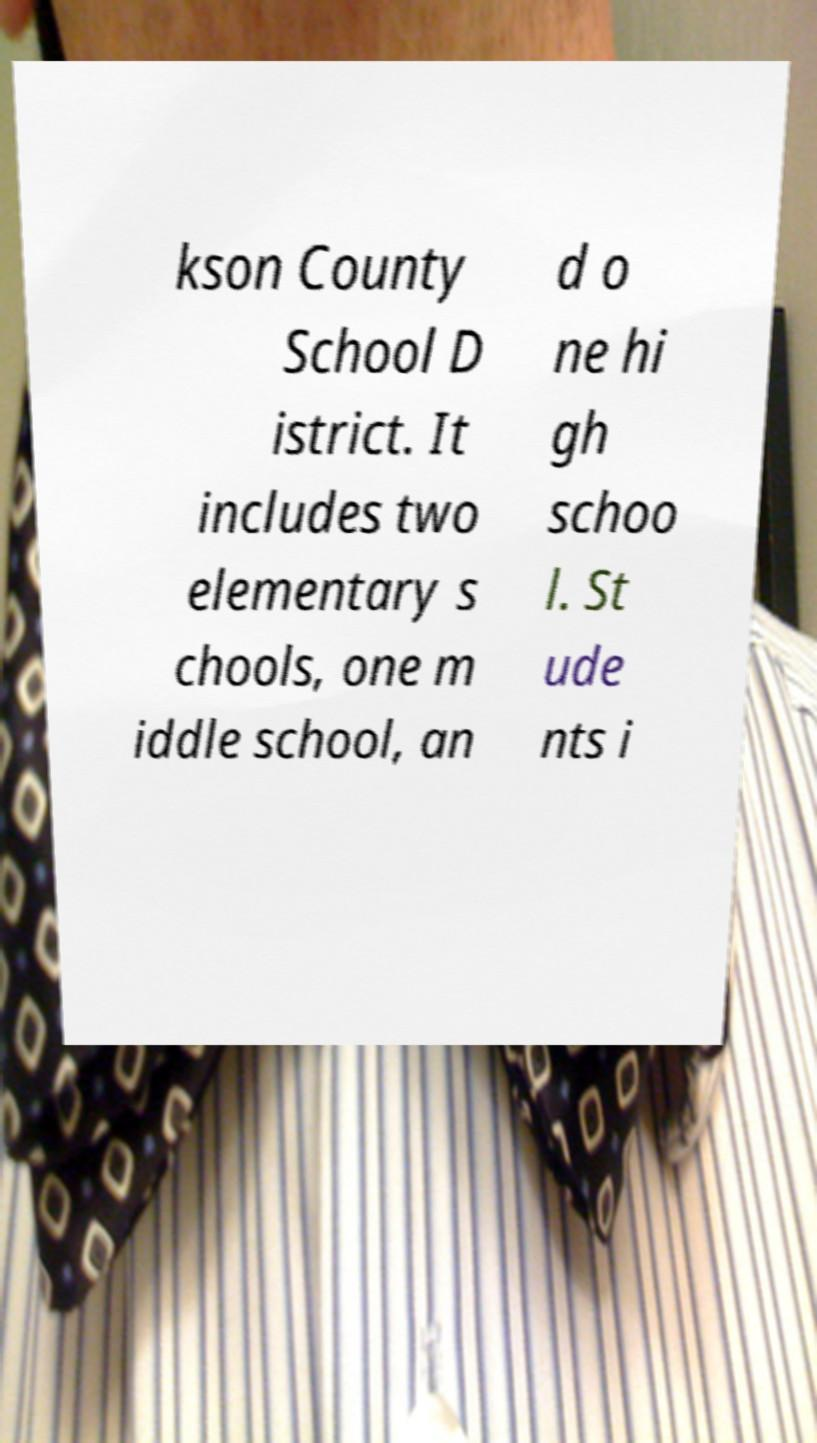There's text embedded in this image that I need extracted. Can you transcribe it verbatim? kson County School D istrict. It includes two elementary s chools, one m iddle school, an d o ne hi gh schoo l. St ude nts i 